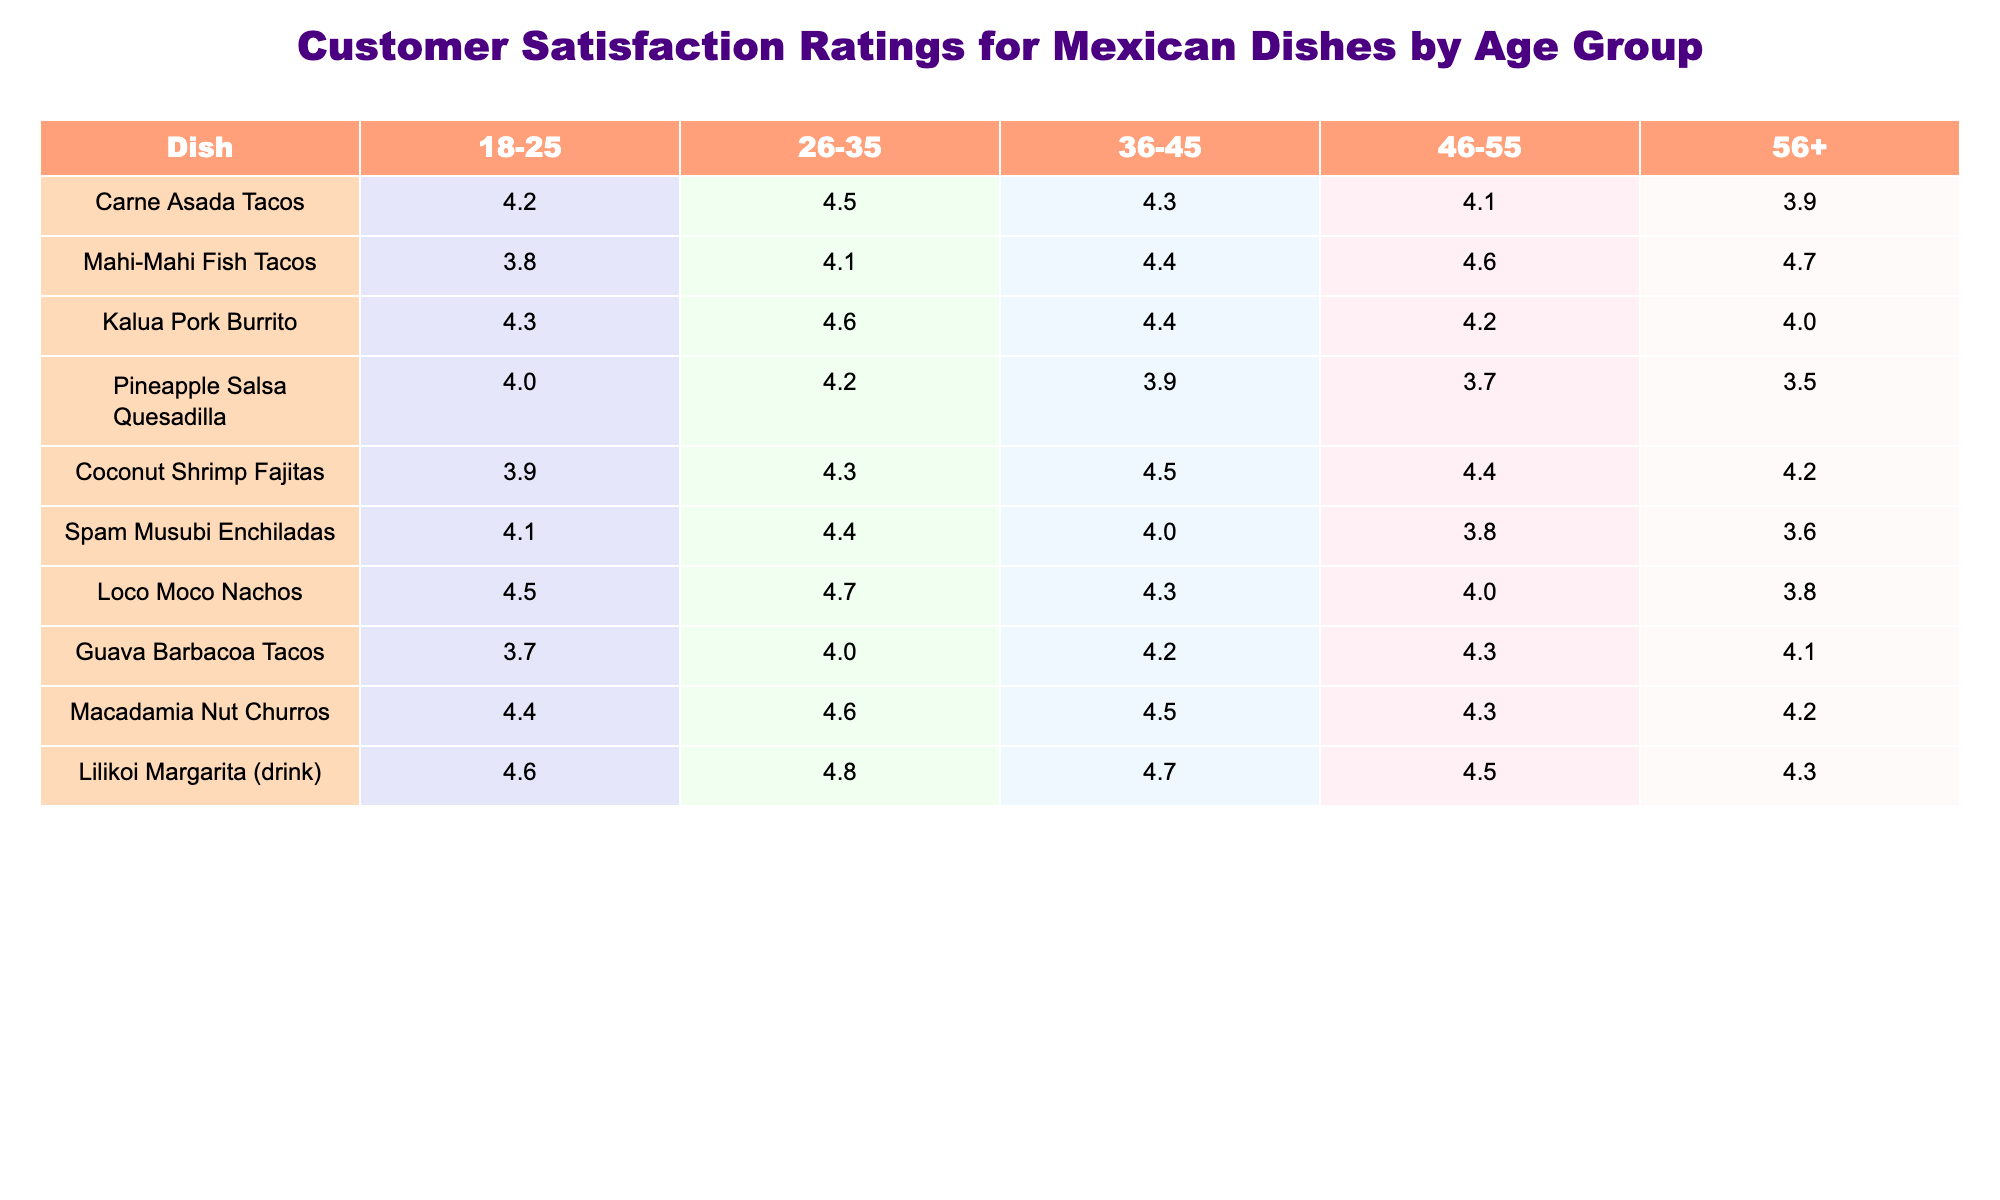What is the highest customer satisfaction rating for the Mahi-Mahi Fish Tacos? Looking at the row for Mahi-Mahi Fish Tacos, the highest rating is found in the age group of 56+, where it has a score of 4.7.
Answer: 4.7 Which dish has the lowest satisfaction rating in the age group of 46-55? In the row for the 46-55 age group, we see that the Pineapple Salsa Quesadilla has the lowest rating of 3.7 among all dishes.
Answer: Pineapple Salsa Quesadilla What is the average rating of the Coconut Shrimp Fajitas across all age groups? To find the average, we sum the ratings: 3.9 + 4.3 + 4.5 + 4.4 + 4.2 = 21.3. Dividing by the number of groups (5), we get 21.3 / 5 = 4.26.
Answer: 4.26 Is the satisfaction rating for Loco Moco Nachos higher than that of Spam Musubi Enchiladas for the 36-45 age group? The ratings show Loco Moco Nachos at 4.3 and Spam Musubi Enchiladas at 4.0 for the 36-45 age group. Since 4.3 is greater than 4.0, the claim is true.
Answer: Yes What is the difference between the highest and lowest ratings for Macadamia Nut Churros across all age groups? The highest rating for Macadamia Nut Churros is 4.6 (age 26-35), and the lowest is 4.2 (age 56+). Calculating the difference: 4.6 - 4.2 = 0.4.
Answer: 0.4 Which dish has the most consistent customer rating across different age groups? By examining the ratings for each dish, the Kalua Pork Burrito has ratings ranging from 4.0 to 4.6, showing less variation compared to others.
Answer: Kalua Pork Burrito In which age group do customers show the highest satisfaction for the Lilikoi Margarita? Checking the ratings for Lilikoi Margarita, it scores the highest in the 26-35 age group with a rating of 4.8.
Answer: 26-35 Are there any dishes with a customer satisfaction rating below 4.0 among the 18-25 age group? Reviewing ratings for the 18-25 age group, Mahi-Mahi Fish Tacos and Guava Barbacoa Tacos both have ratings below 4.0 (3.8 and 3.7 respectively).
Answer: Yes What is the overall trend of customer satisfaction for Carne Asada Tacos from the youngest to the oldest age group? The ratings for Carne Asada Tacos are 4.2, 4.5, 4.3, 4.1, and 3.9 from age 18-25 to 56+. We see a decrease in satisfaction after age 46, indicating a downward trend.
Answer: Downward trend What is the highest rated dish for customers aged 36-45? Looking at the 36-45 age group, Mahi-Mahi Fish Tacos has the highest rating at 4.4.
Answer: Mahi-Mahi Fish Tacos 